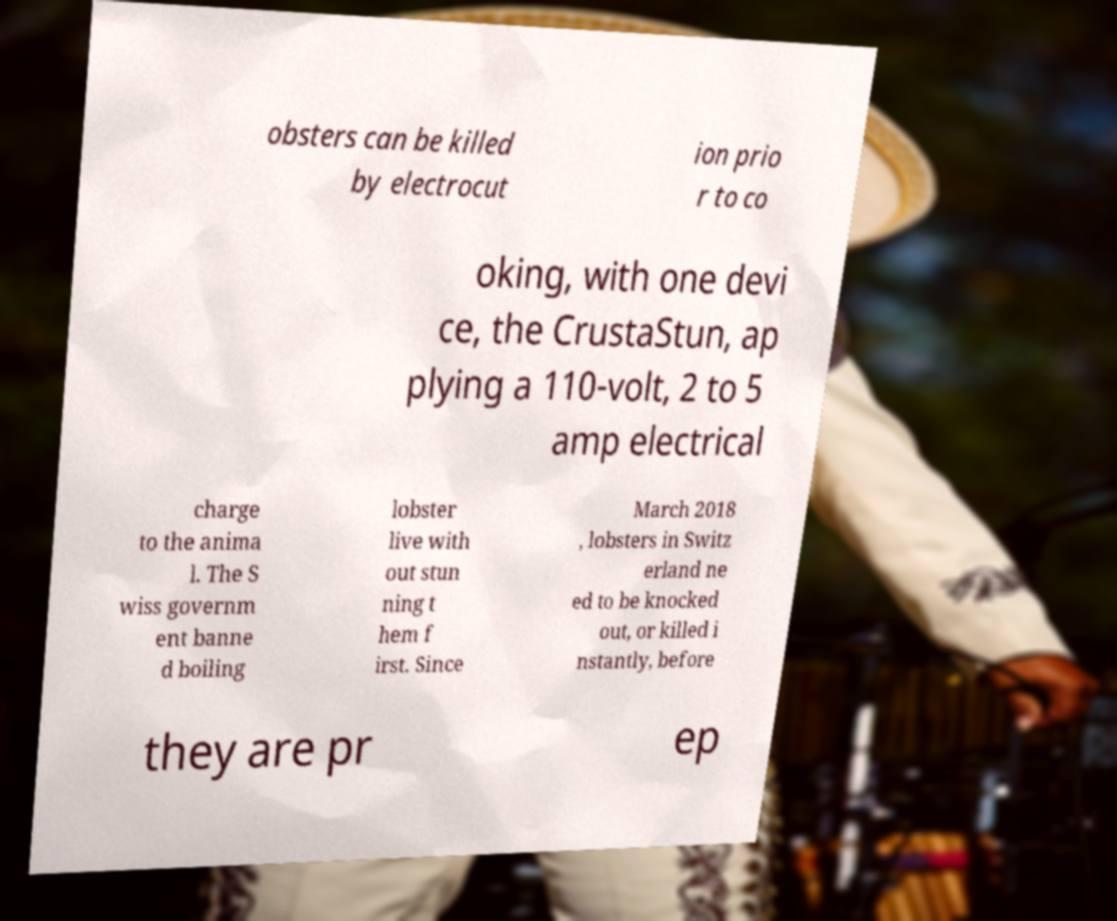I need the written content from this picture converted into text. Can you do that? obsters can be killed by electrocut ion prio r to co oking, with one devi ce, the CrustaStun, ap plying a 110-volt, 2 to 5 amp electrical charge to the anima l. The S wiss governm ent banne d boiling lobster live with out stun ning t hem f irst. Since March 2018 , lobsters in Switz erland ne ed to be knocked out, or killed i nstantly, before they are pr ep 